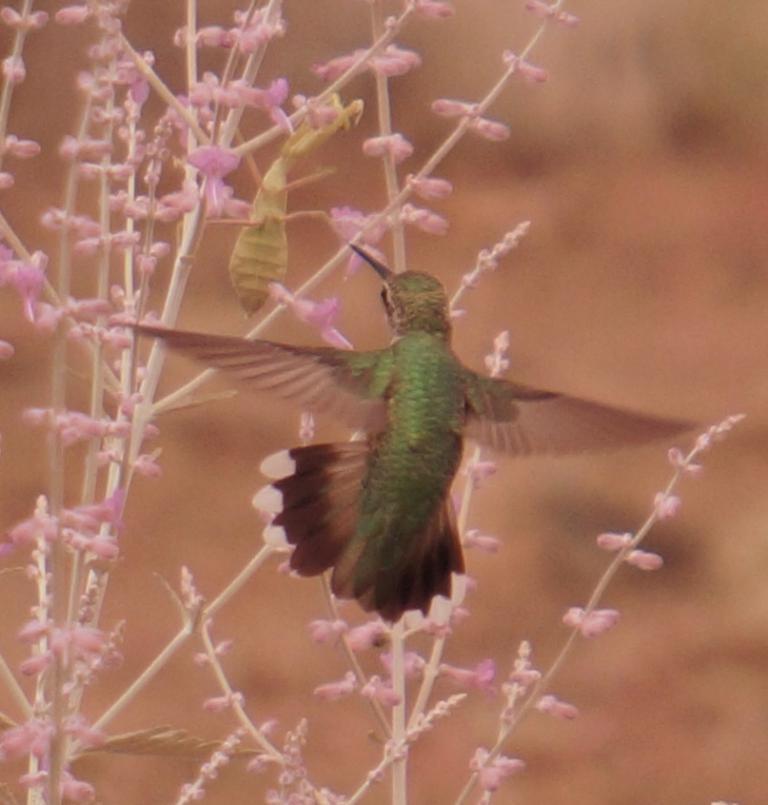In one or two sentences, can you explain what this image depicts? In the middle of the image, there are birds. Beside this bird, there are plants having flowers. And the background is blurred. 